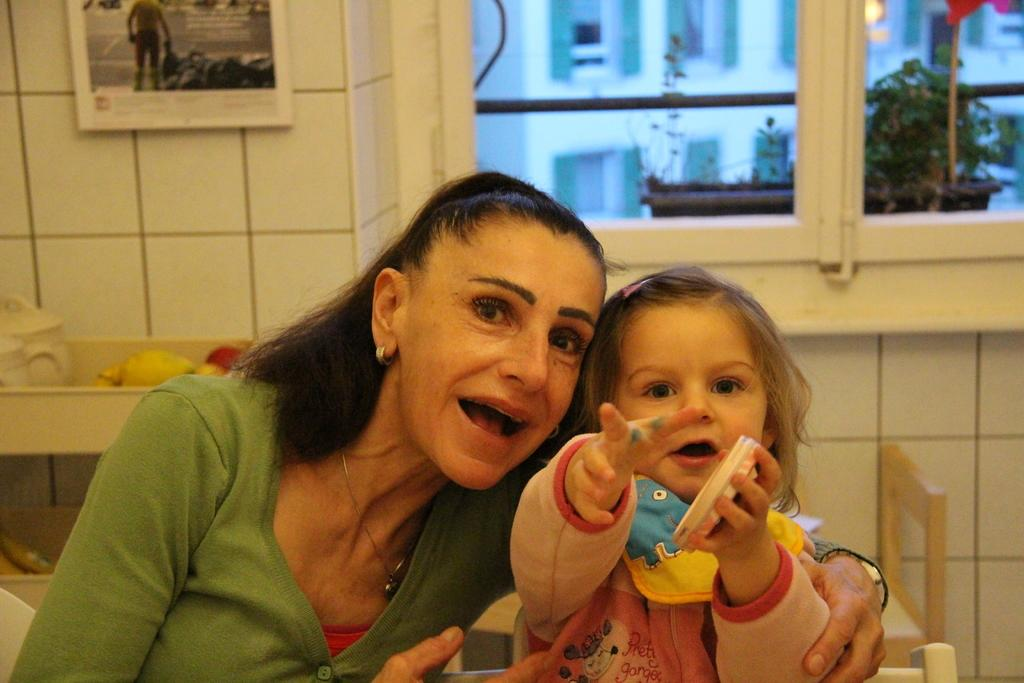What type of flooring is visible in the image? There are white color tiles in the image. What decorative item can be seen in the image? There is a photo frame in the image. What architectural feature is present in the image? There is a window in the image. What type of plant is in the image? There is a plant in the image. What type of storage is available in the image? There are shelves in the image. How many people are present in the image? There are two people in the image. What can be seen outside the window in the image? There are buildings visible outside the window. Can you see a worm crawling on the plant in the image? There is no worm visible on the plant in the image. What type of animal is present in the image? There are no animals present in the image. 